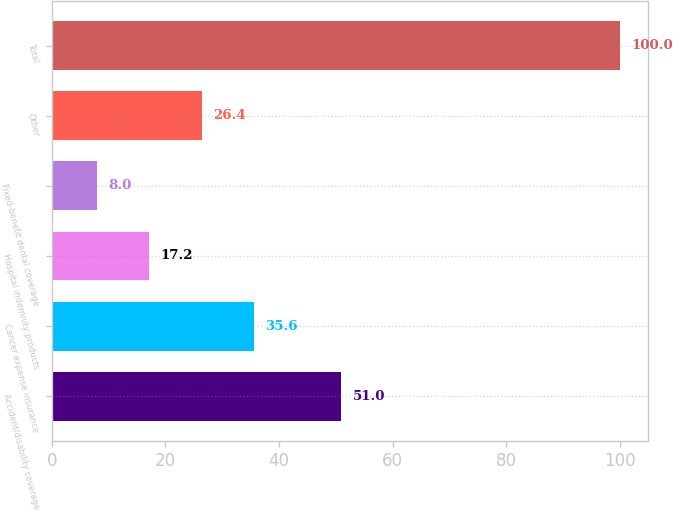Convert chart to OTSL. <chart><loc_0><loc_0><loc_500><loc_500><bar_chart><fcel>Accident/disability coverage<fcel>Cancer expense insurance<fcel>Hospital indemnity products<fcel>Fixed-benefit dental coverage<fcel>Other<fcel>Total<nl><fcel>51<fcel>35.6<fcel>17.2<fcel>8<fcel>26.4<fcel>100<nl></chart> 